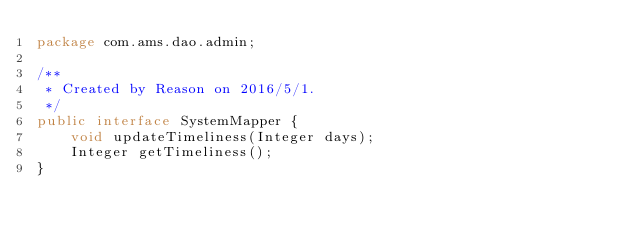Convert code to text. <code><loc_0><loc_0><loc_500><loc_500><_Java_>package com.ams.dao.admin;

/**
 * Created by Reason on 2016/5/1.
 */
public interface SystemMapper {
    void updateTimeliness(Integer days);
    Integer getTimeliness();
}
</code> 